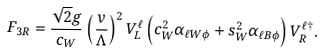Convert formula to latex. <formula><loc_0><loc_0><loc_500><loc_500>F _ { 3 R } = \frac { \sqrt { 2 } g } { c _ { W } } \left ( \frac { v } { \Lambda } \right ) ^ { 2 } V ^ { \ell } _ { L } \left ( c _ { W } ^ { 2 } \alpha _ { { \ell } W \phi } + s _ { W } ^ { 2 } \alpha _ { \ell B \phi } \right ) V ^ { { \ell } \dag } _ { R } .</formula> 